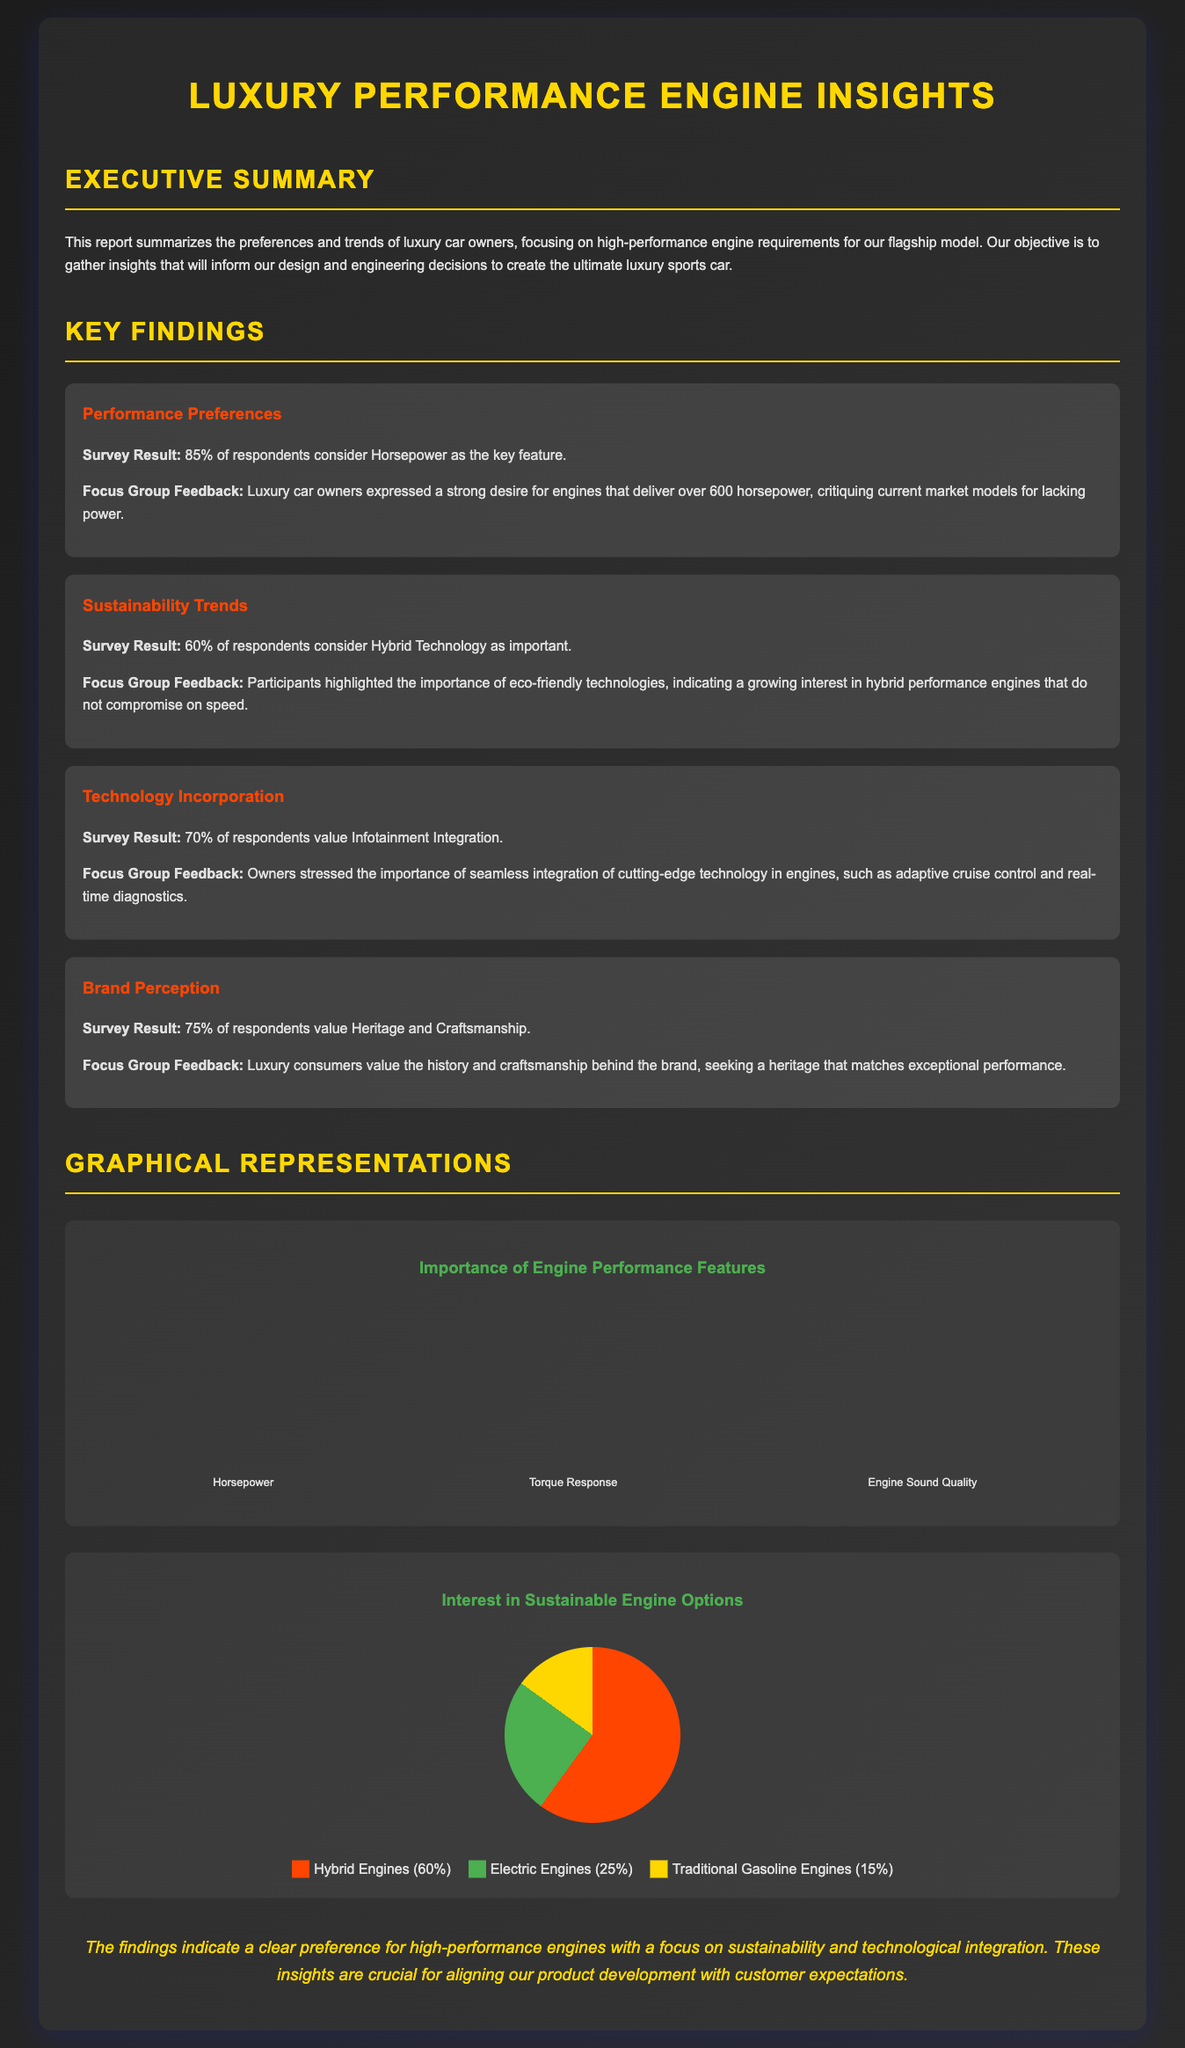What percentage of respondents consider horsepower as key? The document states that 85% of respondents consider horsepower as the key feature.
Answer: 85% What is the interest in hybrid engines according to the pie chart? The pie chart shows that 60% of respondents are interested in hybrid engines.
Answer: 60% How many respondents value heritage and craftsmanship? The key finding states that 75% of respondents value heritage and craftsmanship.
Answer: 75% What is the height of the bar for torque response in the bar chart? The bar for torque response indicates a height representing 75% of respondents.
Answer: 75% What aspect did luxury car owners find lacking in current market models? The focus group feedback indicates that luxury car owners critiqued current market models for lacking power.
Answer: Power Which engine feature is valued by 70% of respondents? The document specifies that 70% of respondents value infotainment integration.
Answer: Infotainment Integration What percentage of respondents consider hybrid technology important? The survey result mentions that 60% of respondents consider hybrid technology as important.
Answer: 60% What color represents electric engines in the pie chart? The legend in the pie chart shows that electric engines are represented by the color green.
Answer: Green Which feature's importance is emphasized in the key findings related to sustainability? Focus Group Feedback highlights the importance of eco-friendly technologies without compromising speed.
Answer: Eco-friendly technologies 